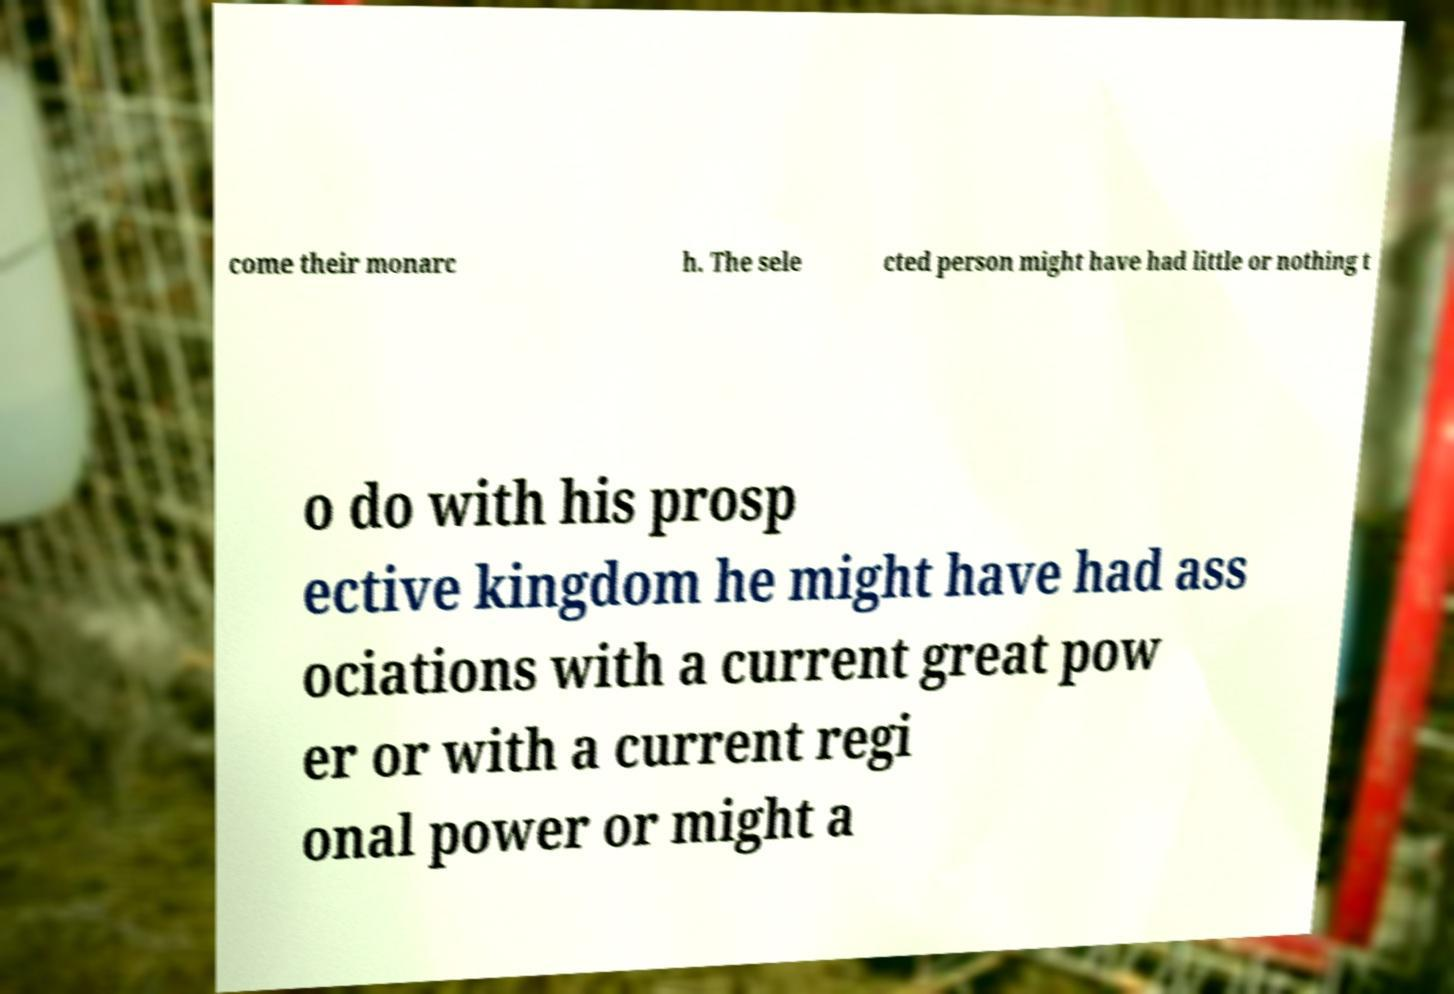For documentation purposes, I need the text within this image transcribed. Could you provide that? come their monarc h. The sele cted person might have had little or nothing t o do with his prosp ective kingdom he might have had ass ociations with a current great pow er or with a current regi onal power or might a 